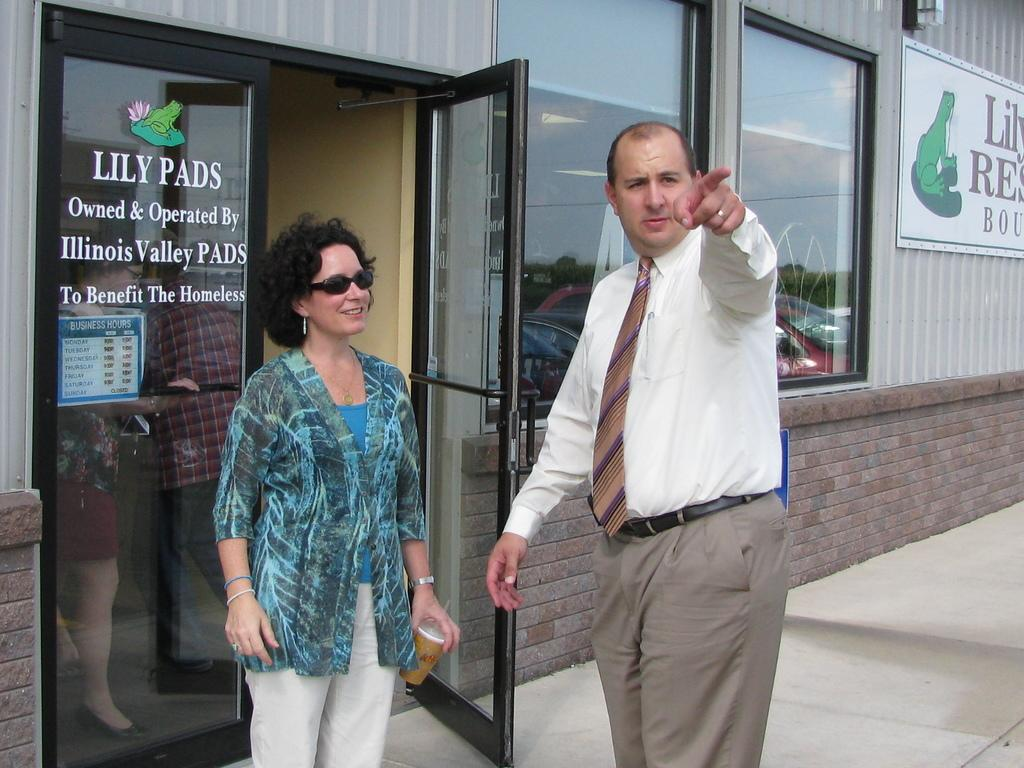How many people are present in the image? There are two people, a man and a woman, present in the image. Where are the man and woman located in the image? The man and woman are in the middle of the image. What can be seen in the background of the image? There is a building in the background of the image. What color is the crayon being used by the man in the image? There is no crayon present in the image; the man and woman are not depicted using any drawing or writing utensils. 